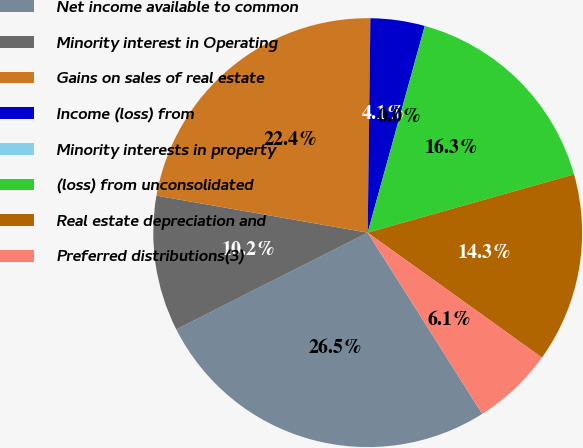Convert chart to OTSL. <chart><loc_0><loc_0><loc_500><loc_500><pie_chart><fcel>Net income available to common<fcel>Minority interest in Operating<fcel>Gains on sales of real estate<fcel>Income (loss) from<fcel>Minority interests in property<fcel>(loss) from unconsolidated<fcel>Real estate depreciation and<fcel>Preferred distributions(3)<nl><fcel>26.52%<fcel>10.21%<fcel>22.44%<fcel>4.09%<fcel>0.01%<fcel>16.32%<fcel>14.28%<fcel>6.13%<nl></chart> 